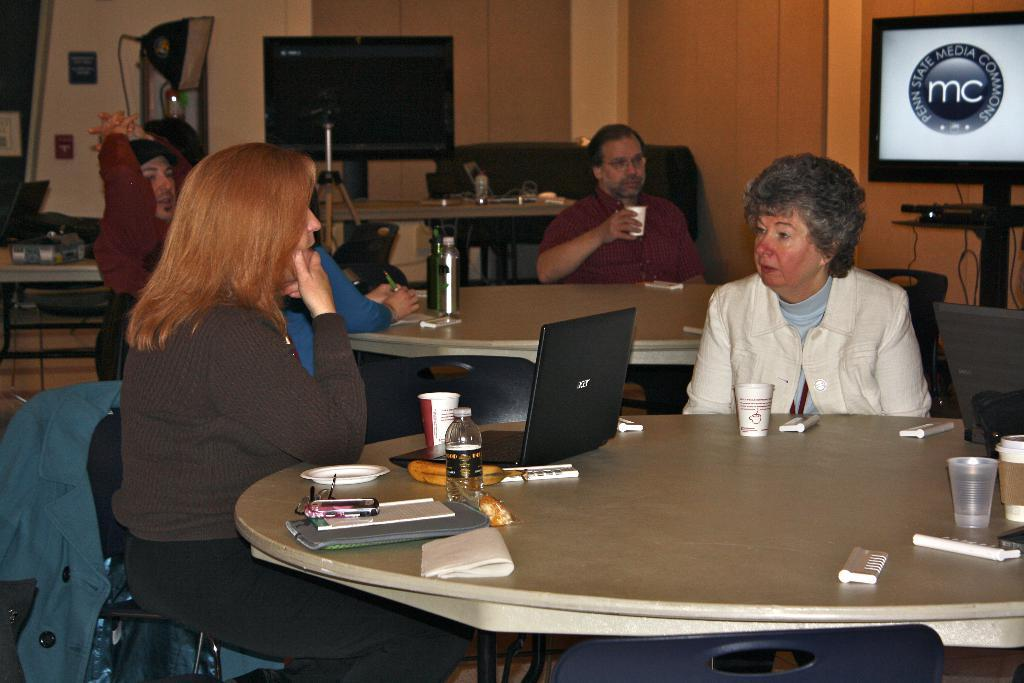What are the people in the image doing? The people in the image are sitting on chairs. What electronic device is on the table? There is a laptop on the table. What beverage container is on the table? There is a water bottle on the table. What type of dishware is on the table? There is a plate on the table. What accessory is on the table? There is a kerchief on the table. What other items are on the table? There are papers and a glass on the table. What is visible on the wall or another surface in the image? There is a TV screen visible in the image. What type of whistle can be heard in the image? There is no whistle present or audible in the image. Is there a flame visible in the image? There is no flame visible in the image. 